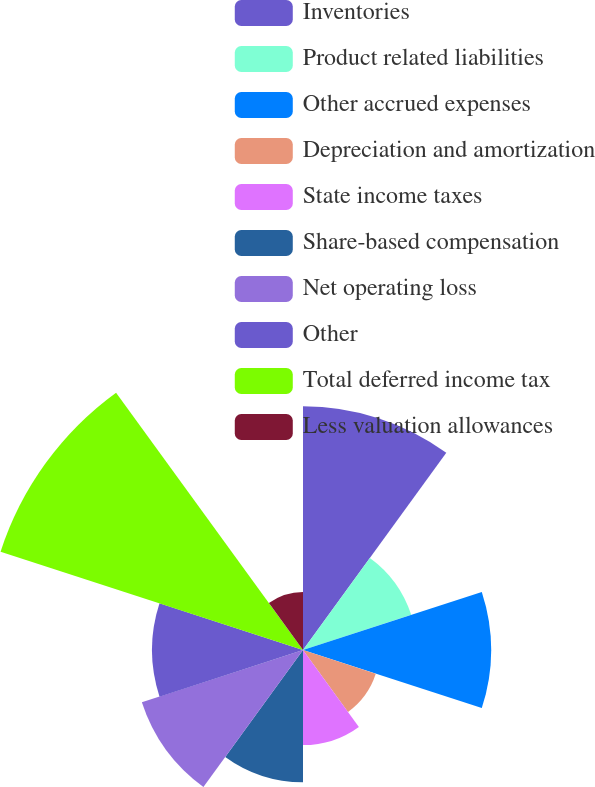Convert chart to OTSL. <chart><loc_0><loc_0><loc_500><loc_500><pie_chart><fcel>Inventories<fcel>Product related liabilities<fcel>Other accrued expenses<fcel>Depreciation and amortization<fcel>State income taxes<fcel>Share-based compensation<fcel>Net operating loss<fcel>Other<fcel>Total deferred income tax<fcel>Less valuation allowances<nl><fcel>15.77%<fcel>7.36%<fcel>12.16%<fcel>4.95%<fcel>6.15%<fcel>8.56%<fcel>10.96%<fcel>9.76%<fcel>20.57%<fcel>3.75%<nl></chart> 